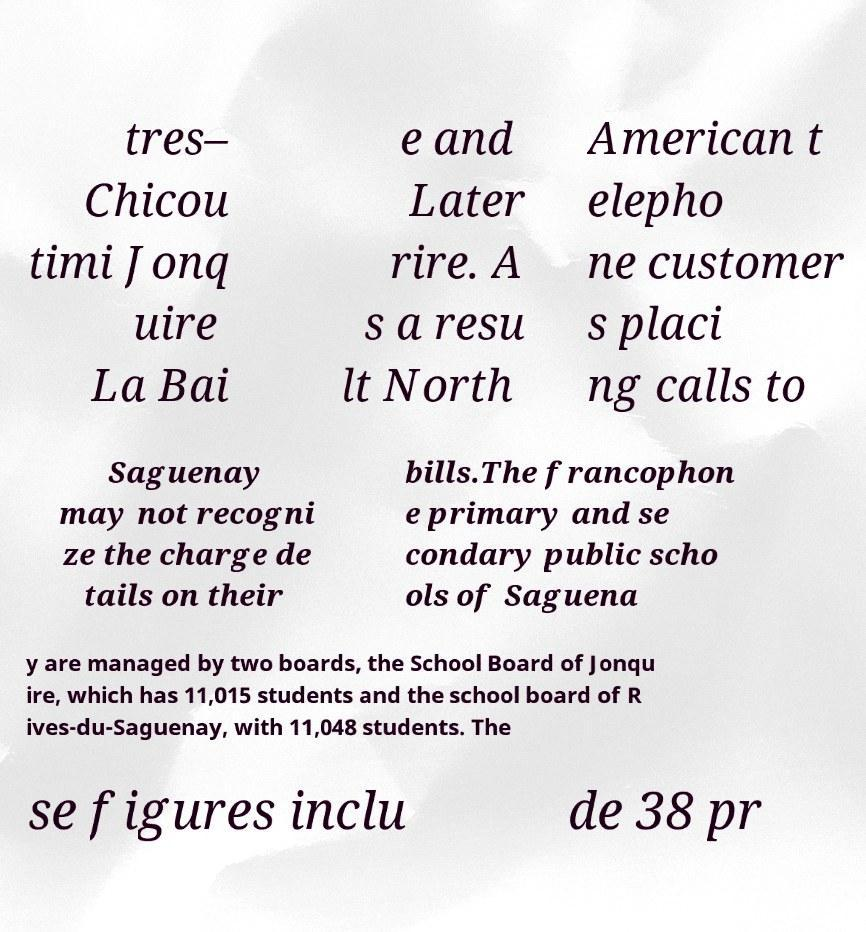Can you read and provide the text displayed in the image?This photo seems to have some interesting text. Can you extract and type it out for me? tres– Chicou timi Jonq uire La Bai e and Later rire. A s a resu lt North American t elepho ne customer s placi ng calls to Saguenay may not recogni ze the charge de tails on their bills.The francophon e primary and se condary public scho ols of Saguena y are managed by two boards, the School Board of Jonqu ire, which has 11,015 students and the school board of R ives-du-Saguenay, with 11,048 students. The se figures inclu de 38 pr 